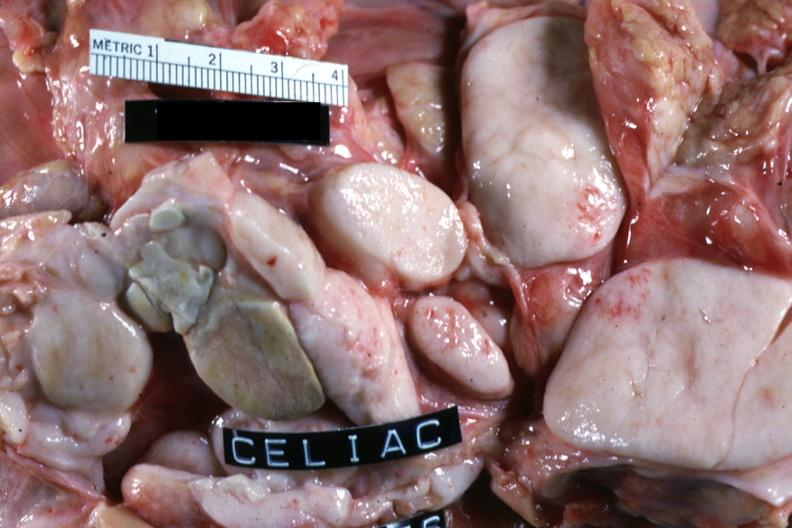s carcinoma present?
Answer the question using a single word or phrase. No 